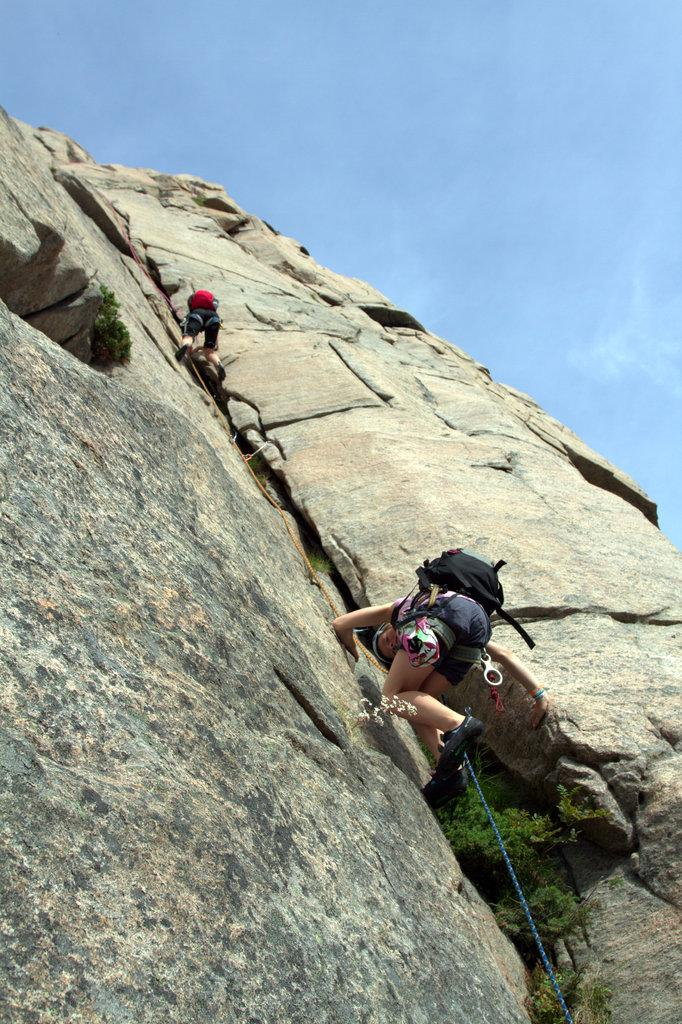How many people are in the image? There are two people in the image. What are the two people doing in the image? The two people are climbing a mountain. What object can be seen assisting the climbers in the image? There is a rope in the image. What is visible at the top of the image? The sky is visible at the top of the image. Can you see any wounds on the climbers in the image? There is no indication of any wounds on the climbers in the image. Are there any dinosaurs visible in the image? There are no dinosaurs present in the image; it features two people climbing a mountain. 